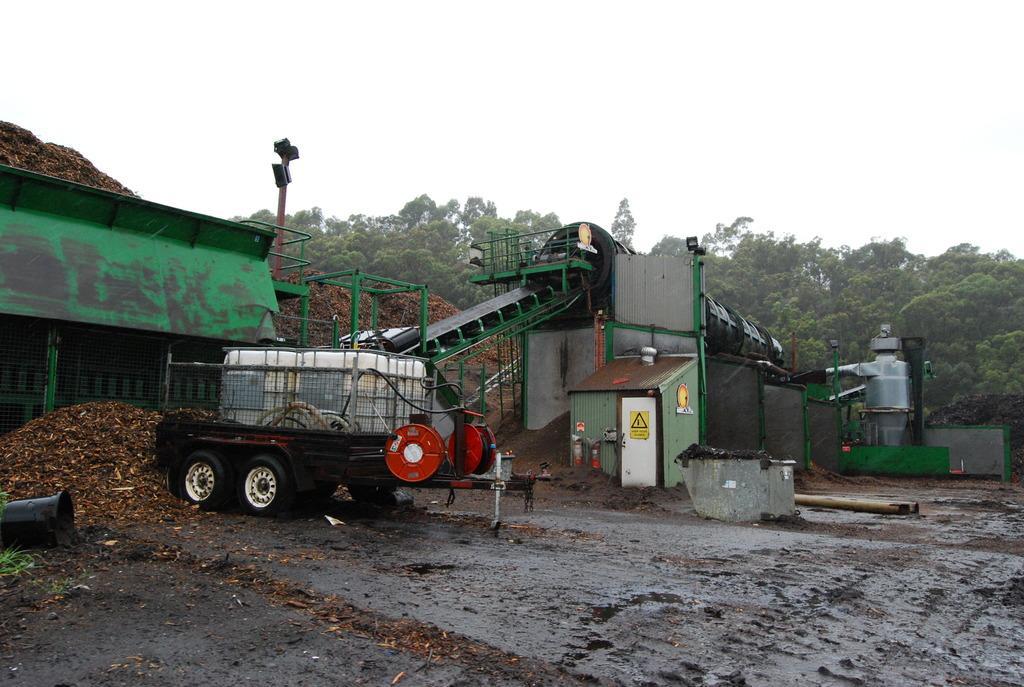Please provide a concise description of this image. In this image in the center there is a vehicle and shed, and in the background there are some trees and some dry leaves. At the bottom there is sand and there is one pole and also there are some objects, at the top of the image there is sky. 